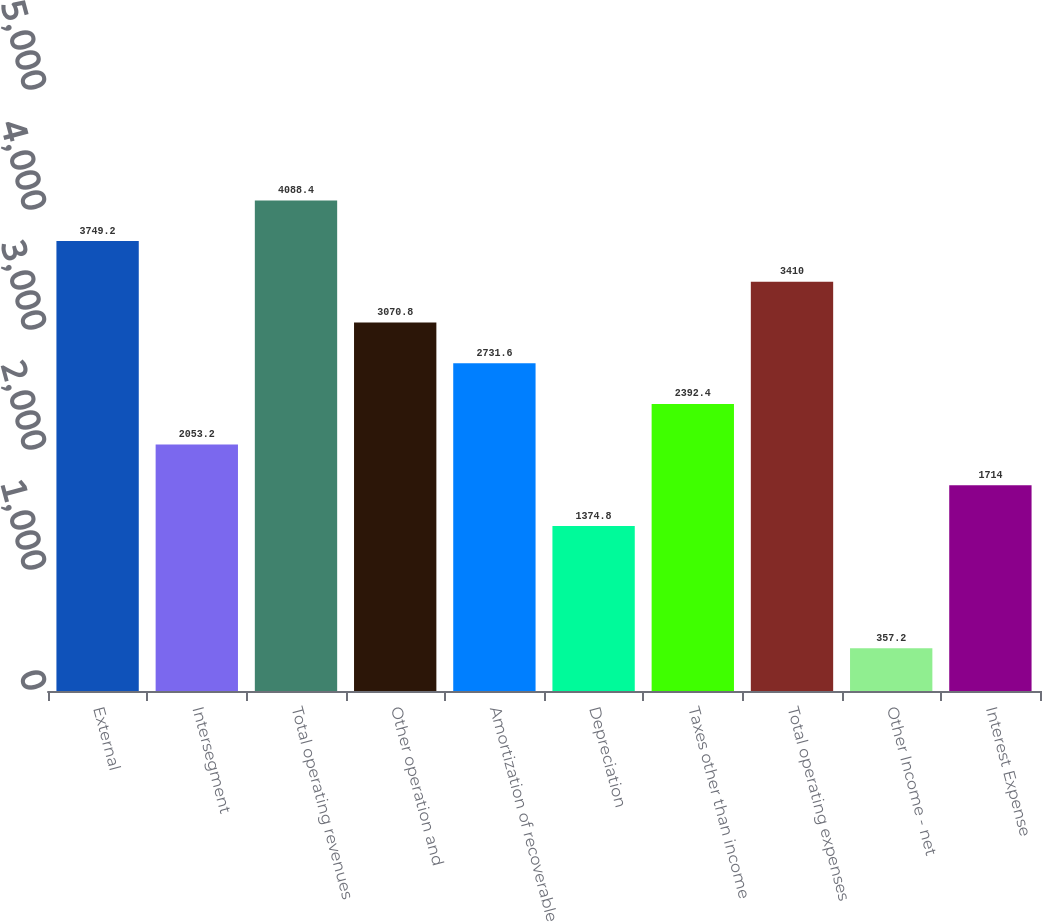Convert chart. <chart><loc_0><loc_0><loc_500><loc_500><bar_chart><fcel>External<fcel>Intersegment<fcel>Total operating revenues<fcel>Other operation and<fcel>Amortization of recoverable<fcel>Depreciation<fcel>Taxes other than income<fcel>Total operating expenses<fcel>Other Income - net<fcel>Interest Expense<nl><fcel>3749.2<fcel>2053.2<fcel>4088.4<fcel>3070.8<fcel>2731.6<fcel>1374.8<fcel>2392.4<fcel>3410<fcel>357.2<fcel>1714<nl></chart> 